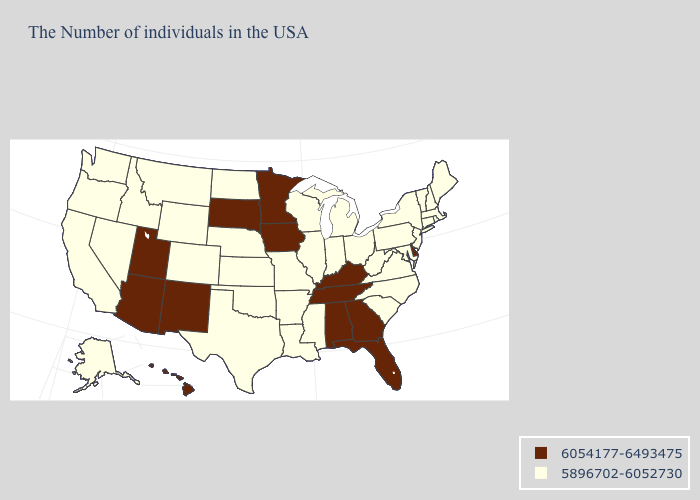Among the states that border Missouri , does Illinois have the highest value?
Write a very short answer. No. Does Arizona have the highest value in the West?
Give a very brief answer. Yes. What is the highest value in states that border North Carolina?
Write a very short answer. 6054177-6493475. What is the value of New Mexico?
Write a very short answer. 6054177-6493475. What is the lowest value in states that border Delaware?
Give a very brief answer. 5896702-6052730. What is the value of Georgia?
Quick response, please. 6054177-6493475. What is the lowest value in states that border Vermont?
Be succinct. 5896702-6052730. What is the value of Kansas?
Concise answer only. 5896702-6052730. Does the map have missing data?
Give a very brief answer. No. What is the highest value in states that border North Dakota?
Quick response, please. 6054177-6493475. Name the states that have a value in the range 6054177-6493475?
Keep it brief. Delaware, Florida, Georgia, Kentucky, Alabama, Tennessee, Minnesota, Iowa, South Dakota, New Mexico, Utah, Arizona, Hawaii. Among the states that border Indiana , does Kentucky have the highest value?
Give a very brief answer. Yes. What is the lowest value in the Northeast?
Keep it brief. 5896702-6052730. 